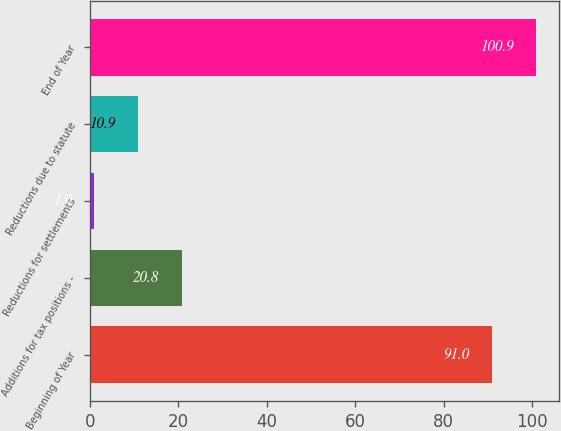<chart> <loc_0><loc_0><loc_500><loc_500><bar_chart><fcel>Beginning of Year<fcel>Additions for tax positions -<fcel>Reductions for settlements<fcel>Reductions due to statute<fcel>End of Year<nl><fcel>91<fcel>20.8<fcel>1<fcel>10.9<fcel>100.9<nl></chart> 